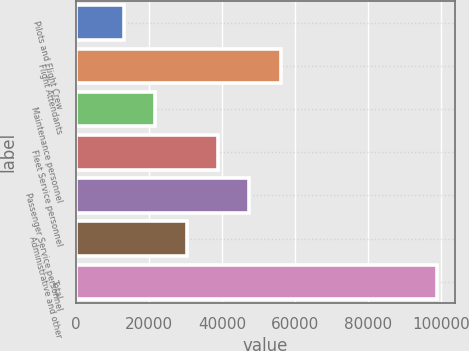Convert chart. <chart><loc_0><loc_0><loc_500><loc_500><bar_chart><fcel>Pilots and Flight Crew<fcel>Flight Attendants<fcel>Maintenance personnel<fcel>Fleet Service personnel<fcel>Passenger Service personnel<fcel>Administrative and other<fcel>Total<nl><fcel>13100<fcel>56000<fcel>21680<fcel>38840<fcel>47420<fcel>30260<fcel>98900<nl></chart> 